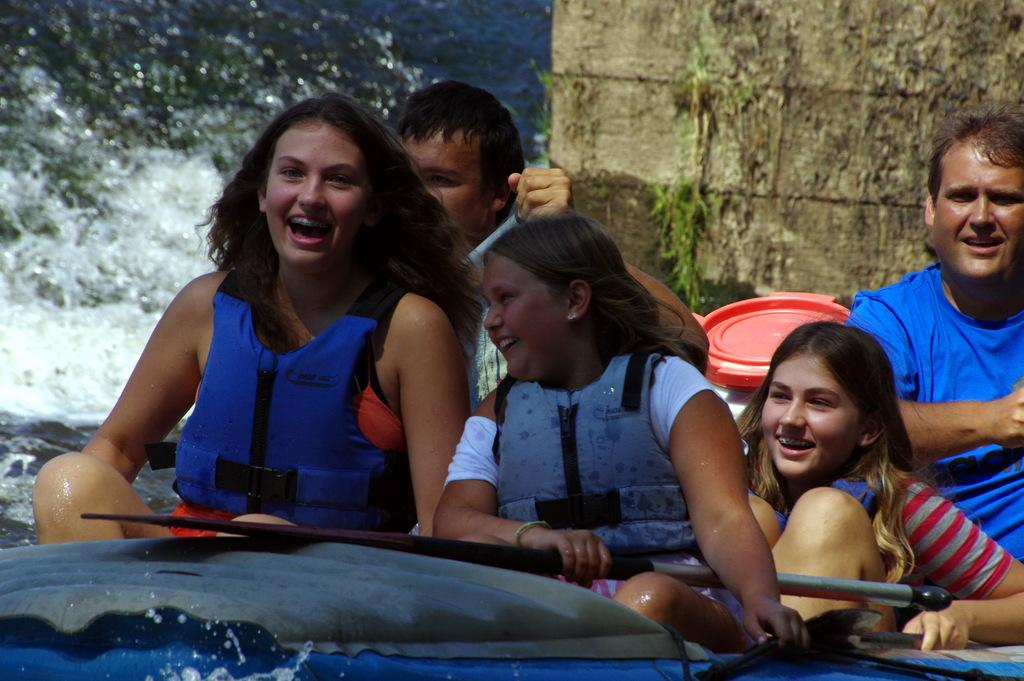What are the people in the image doing? The people in the image are sitting on a boat. What is the girl in the image holding? The girl in the image is holding a paddle. What can be seen in the background of the image? There is a wall visible in the image. What is the primary setting of the image? There is water visible in the image, so the primary setting is on or near water. How many scarecrows are present in the image? There are no scarecrows present in the image. What type of army is depicted in the image? There is no army depicted in the image. 